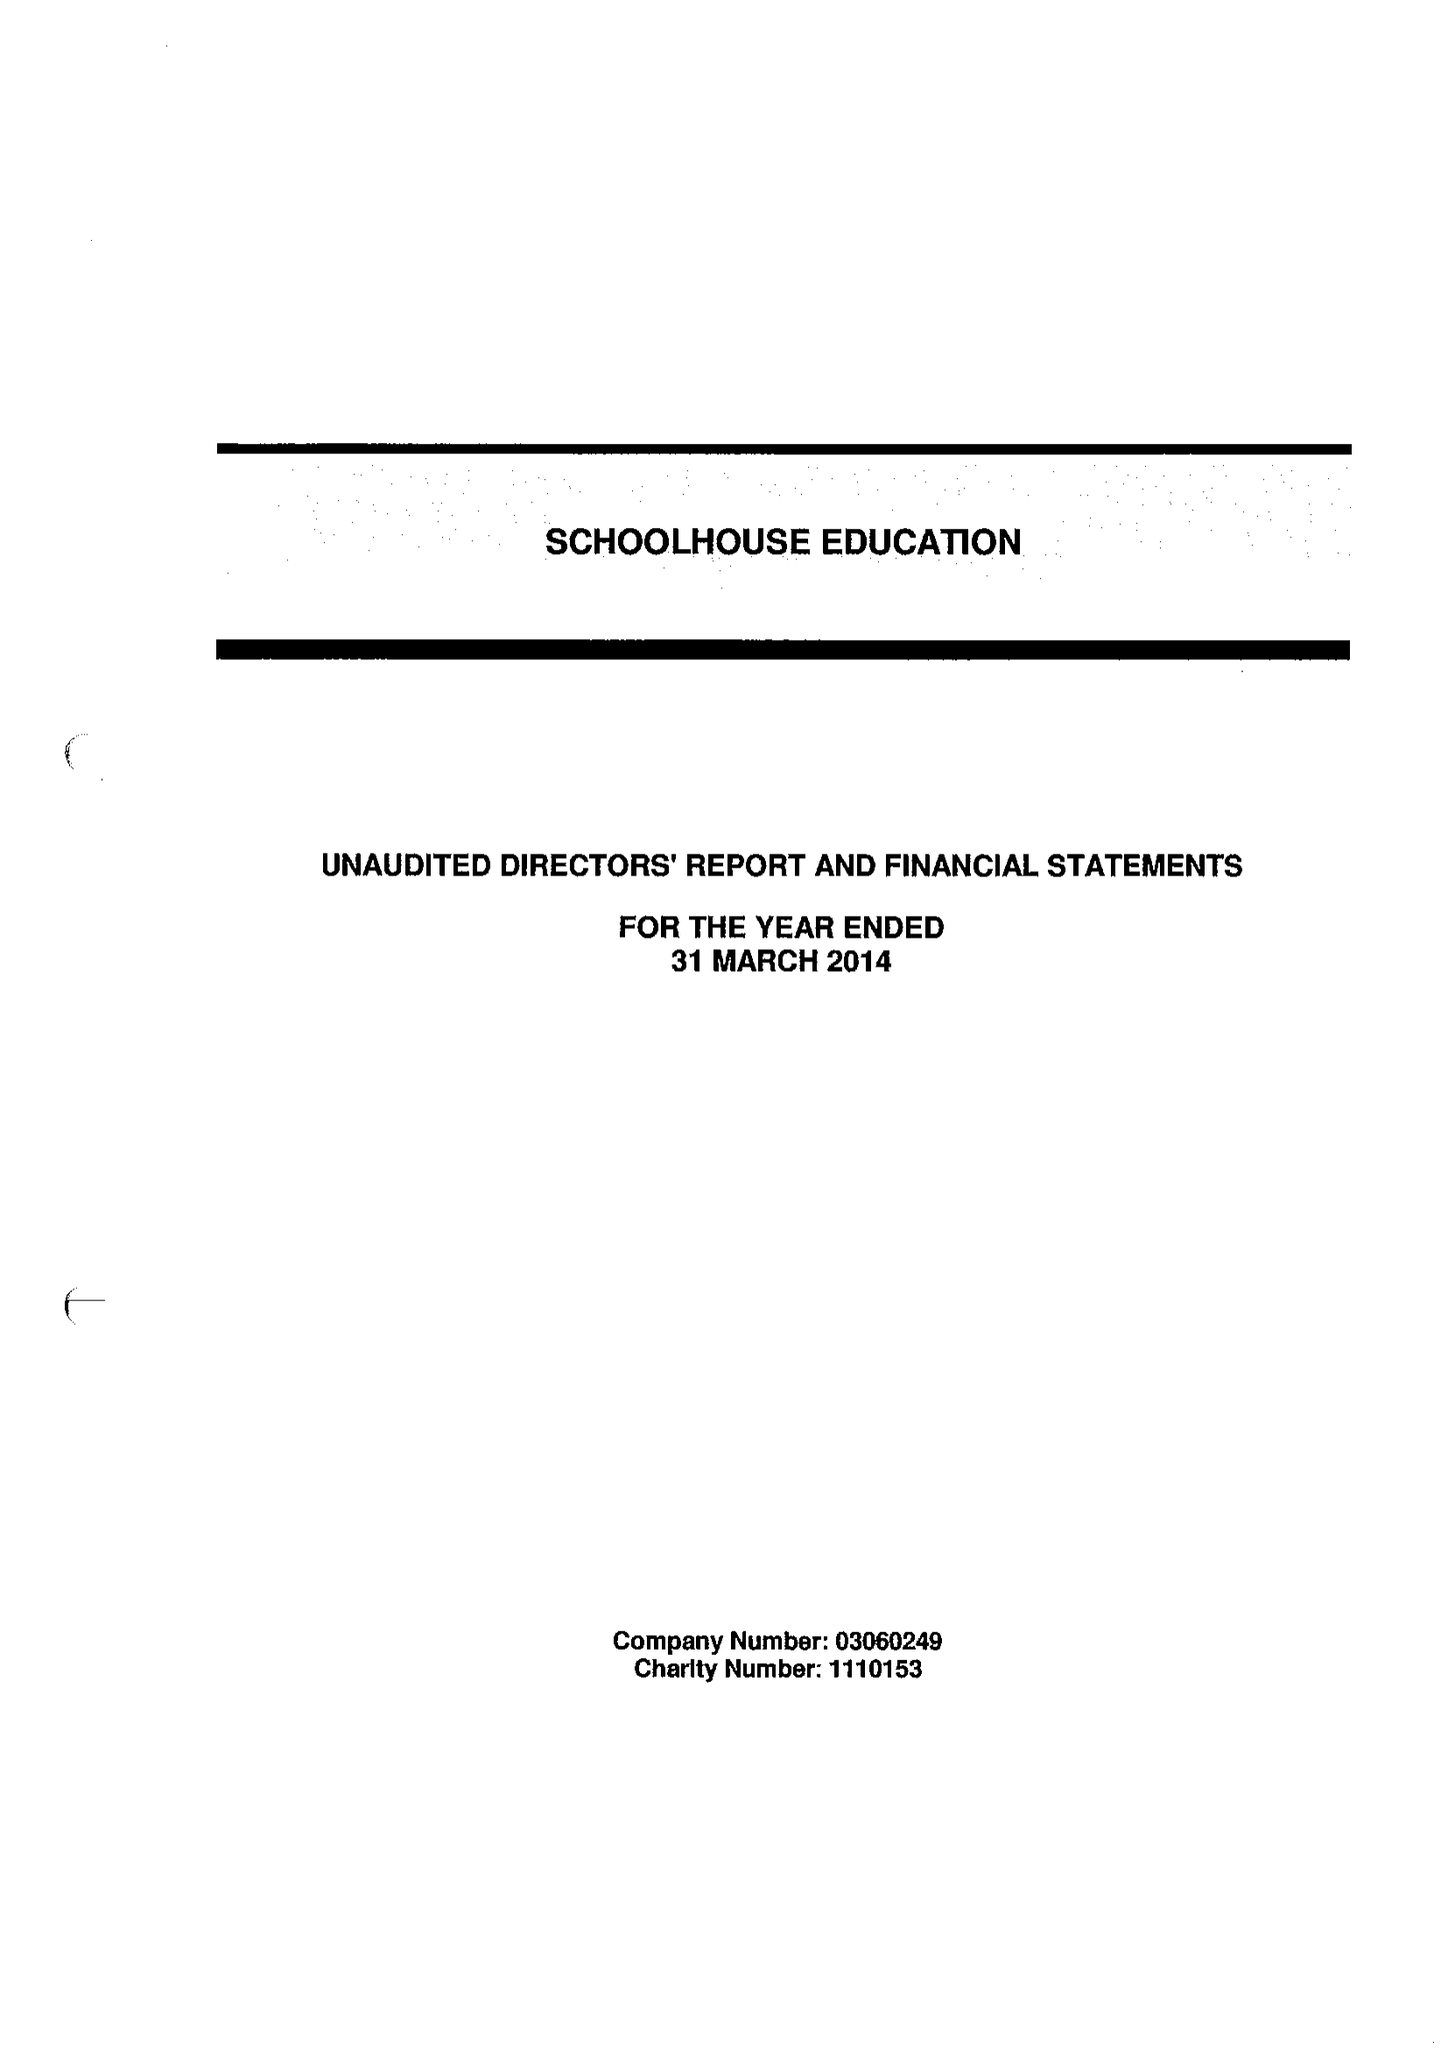What is the value for the address__post_town?
Answer the question using a single word or phrase. LONDON 